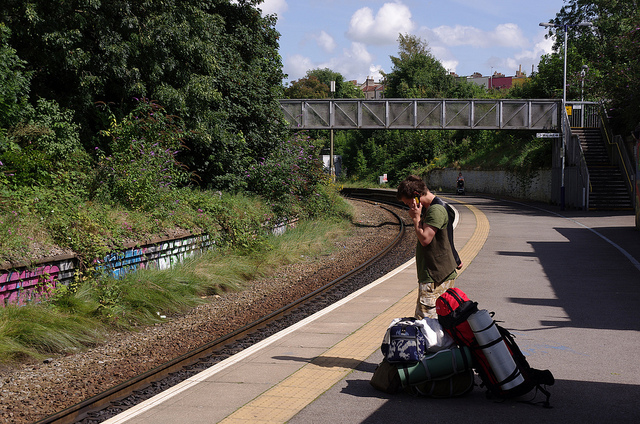What activities might the person be planning with all that gear? The person appears to be preparing for an outdoor adventure, such as camping, hiking, or backpacking. The amount of gear suggests a multi-day trip, potentially in a natural setting where self-sufficiency is crucial. 